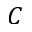<formula> <loc_0><loc_0><loc_500><loc_500>C</formula> 